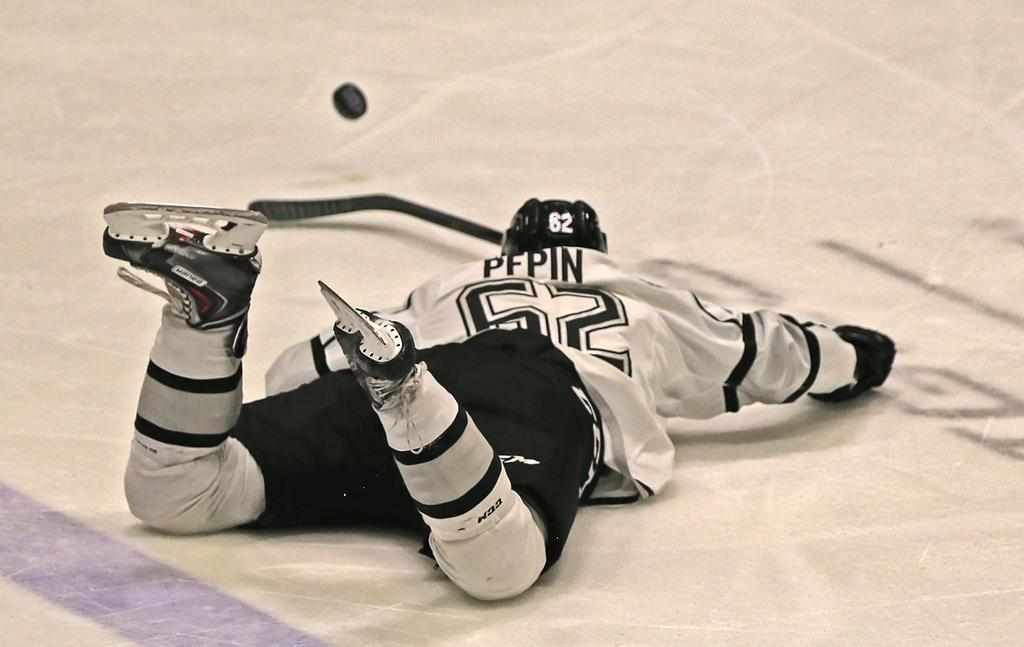<image>
Render a clear and concise summary of the photo. An icehockey player called Pepin wearing black and white is sprawled on the ice watching the puck scoot away from him. 